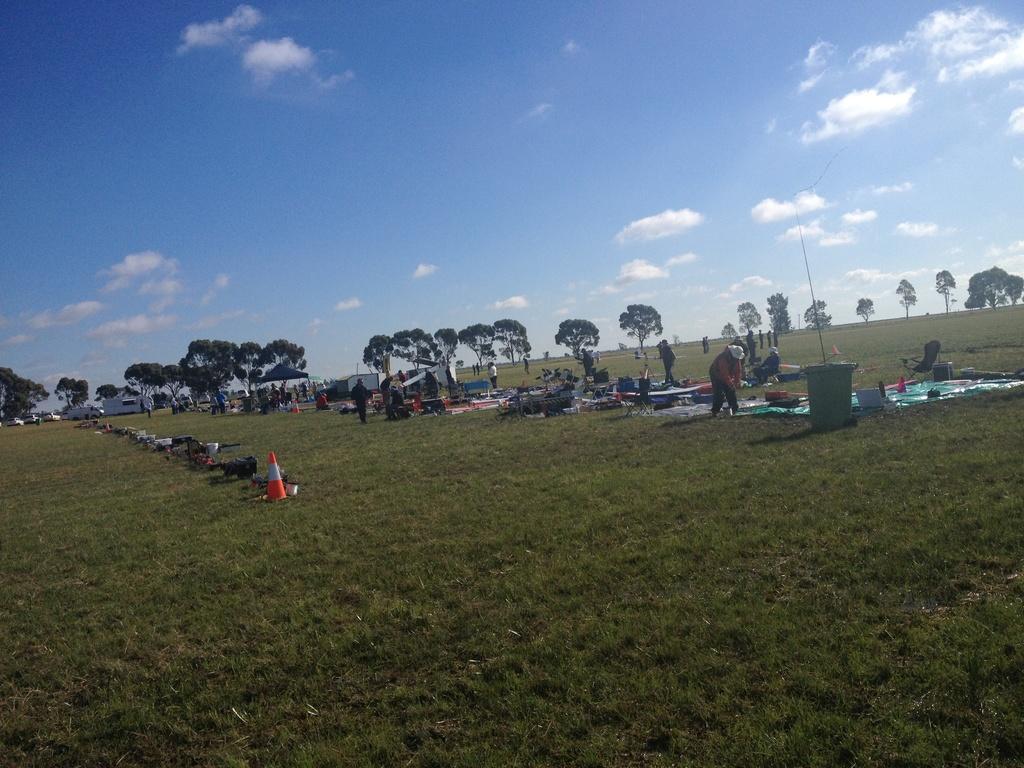Describe this image in one or two sentences. This is an outside view. It is looking like a ground. Here I can see few people are standing and there are some objects on the ground like sheets, chairs, bowls, bags and some more objects. In the background there are some cars, houses and trees. On the top of the image I can see the sky and clouds. 